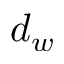Convert formula to latex. <formula><loc_0><loc_0><loc_500><loc_500>d _ { w }</formula> 